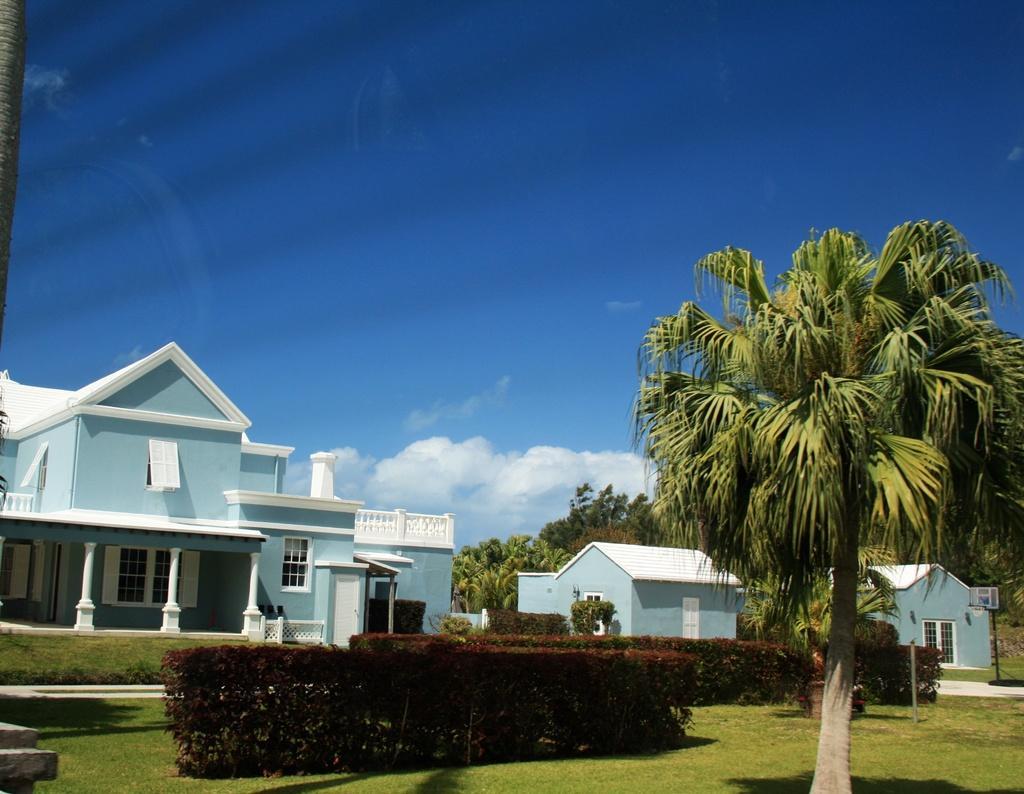Can you describe this image briefly? In this image I can see few houses, windows, trees and small plants. I can see the basketball goal post. The sky is in blue and white color. 